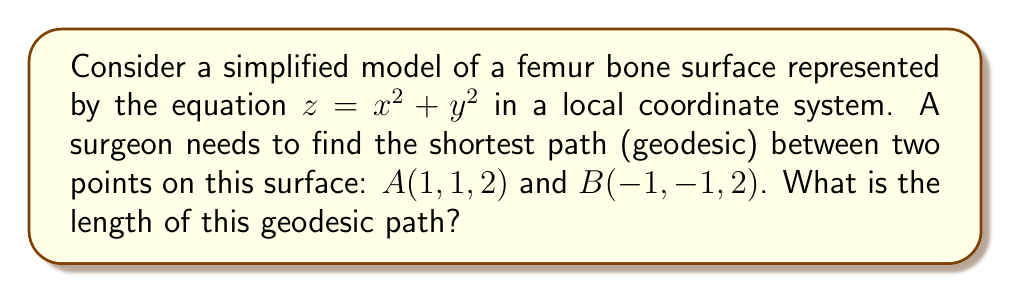Could you help me with this problem? Let's approach this step-by-step:

1) The surface is a paraboloid, which is a quadric surface. For such surfaces, the geodesics are generally not straight lines in 3D space.

2) However, due to the symmetry of this particular surface, we can deduce that the geodesic between the given points will be a plane curve lying in the vertical plane that contains both points and the z-axis.

3) We can parameterize this plane curve as:
   $x(t) = t$
   $y(t) = t$
   $z(t) = 2t^2$
   where $-1 \leq t \leq 1$

4) The length of a curve in 3D space is given by the integral:

   $$L = \int_{-1}^{1} \sqrt{(\frac{dx}{dt})^2 + (\frac{dy}{dt})^2 + (\frac{dz}{dt})^2} dt$$

5) Substituting our parameterization:

   $$L = \int_{-1}^{1} \sqrt{1^2 + 1^2 + (4t)^2} dt = \int_{-1}^{1} \sqrt{2 + 16t^2} dt$$

6) This integral can be solved using the substitution $u = 4t$:

   $$L = \frac{1}{4} \int_{-4}^{4} \sqrt{2 + u^2} du$$

7) The result of this integral is:

   $$L = \frac{1}{4} [\frac{u}{2}\sqrt{u^2+2} + \ln(u + \sqrt{u^2+2})]_{-4}^{4}$$

8) Evaluating at the limits:

   $$L = \frac{1}{4} [2\sqrt{18} + \ln(4 + \sqrt{18}) - (-2\sqrt{18} + \ln(-4 + \sqrt{18}))]$$

9) Simplifying:

   $$L = \frac{1}{2}\sqrt{18} + \frac{1}{4}\ln(\frac{4 + \sqrt{18}}{-4 + \sqrt{18}})$$
Answer: $\frac{1}{2}\sqrt{18} + \frac{1}{4}\ln(\frac{4 + \sqrt{18}}{-4 + \sqrt{18}})$ 